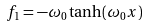Convert formula to latex. <formula><loc_0><loc_0><loc_500><loc_500>f _ { 1 } = - \omega _ { 0 } \tanh ( \omega _ { 0 } x )</formula> 